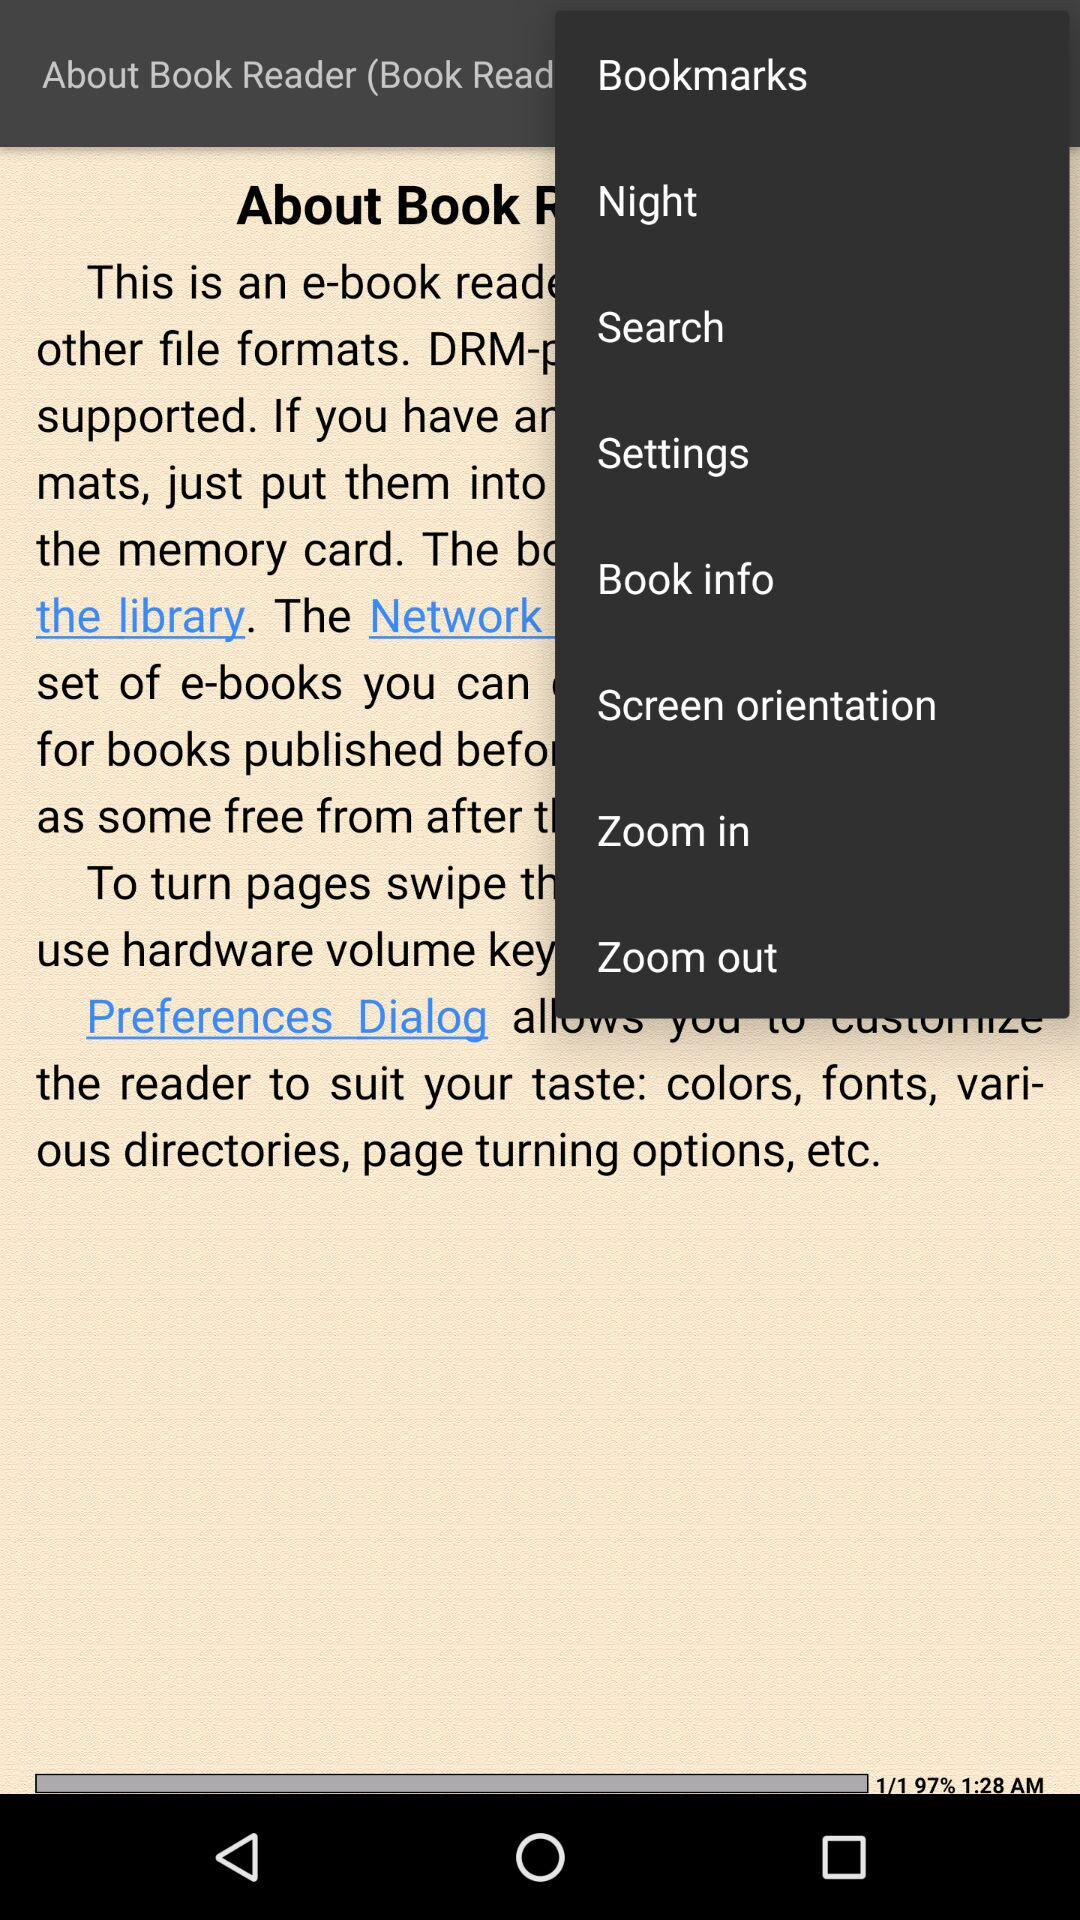What is the time? The time is 1:28 a.m. 